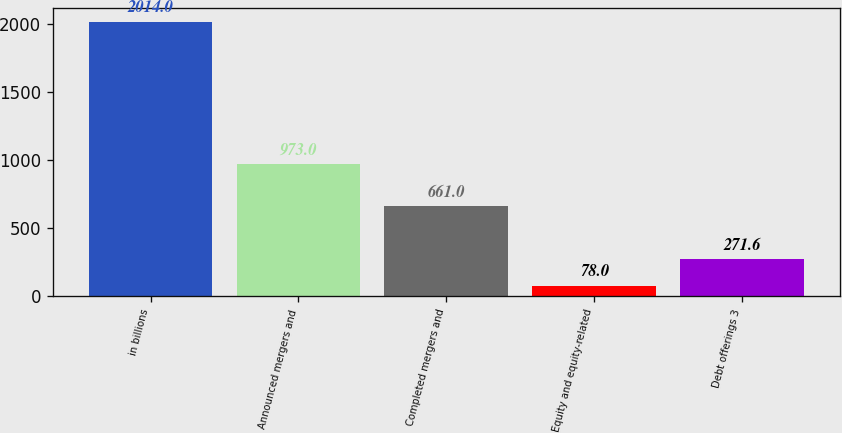Convert chart. <chart><loc_0><loc_0><loc_500><loc_500><bar_chart><fcel>in billions<fcel>Announced mergers and<fcel>Completed mergers and<fcel>Equity and equity-related<fcel>Debt offerings 3<nl><fcel>2014<fcel>973<fcel>661<fcel>78<fcel>271.6<nl></chart> 